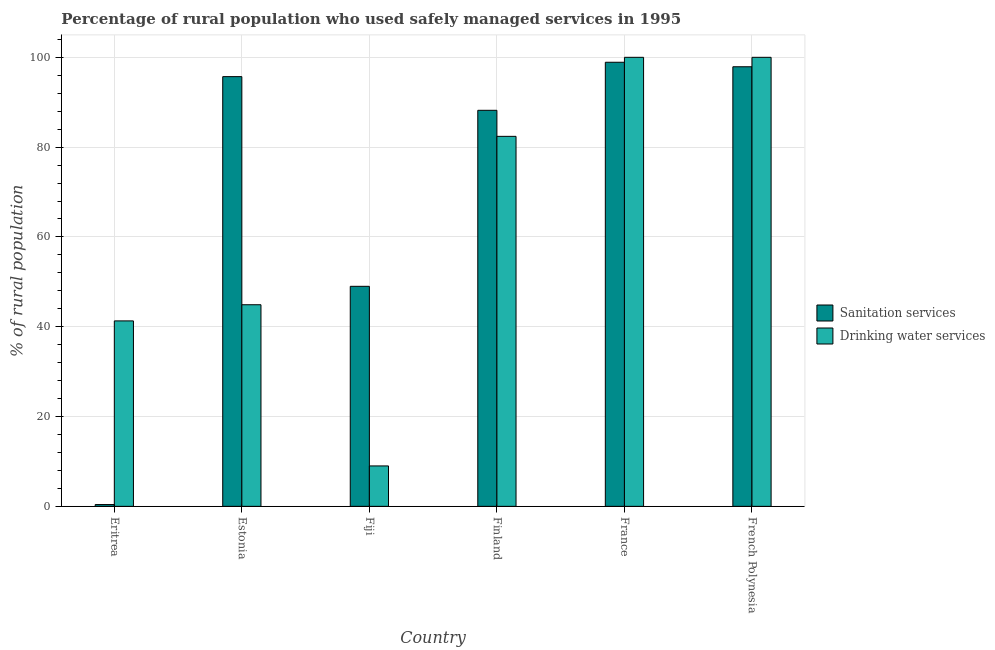How many different coloured bars are there?
Offer a terse response. 2. How many groups of bars are there?
Keep it short and to the point. 6. What is the label of the 2nd group of bars from the left?
Offer a very short reply. Estonia. In how many cases, is the number of bars for a given country not equal to the number of legend labels?
Provide a short and direct response. 0. What is the percentage of rural population who used sanitation services in France?
Ensure brevity in your answer.  98.9. Across all countries, what is the maximum percentage of rural population who used sanitation services?
Ensure brevity in your answer.  98.9. Across all countries, what is the minimum percentage of rural population who used drinking water services?
Your answer should be very brief. 9. In which country was the percentage of rural population who used sanitation services maximum?
Ensure brevity in your answer.  France. In which country was the percentage of rural population who used sanitation services minimum?
Offer a terse response. Eritrea. What is the total percentage of rural population who used drinking water services in the graph?
Keep it short and to the point. 377.6. What is the difference between the percentage of rural population who used drinking water services in Estonia and that in France?
Offer a very short reply. -55.1. What is the difference between the percentage of rural population who used sanitation services in Fiji and the percentage of rural population who used drinking water services in Eritrea?
Offer a very short reply. 7.7. What is the average percentage of rural population who used drinking water services per country?
Ensure brevity in your answer.  62.93. What is the difference between the percentage of rural population who used drinking water services and percentage of rural population who used sanitation services in Finland?
Keep it short and to the point. -5.8. In how many countries, is the percentage of rural population who used sanitation services greater than 28 %?
Your answer should be very brief. 5. What is the ratio of the percentage of rural population who used drinking water services in Estonia to that in Fiji?
Your answer should be compact. 4.99. Is the difference between the percentage of rural population who used drinking water services in Finland and France greater than the difference between the percentage of rural population who used sanitation services in Finland and France?
Your answer should be compact. No. What is the difference between the highest and the lowest percentage of rural population who used sanitation services?
Offer a terse response. 98.5. What does the 1st bar from the left in Finland represents?
Provide a succinct answer. Sanitation services. What does the 1st bar from the right in Finland represents?
Your response must be concise. Drinking water services. How many bars are there?
Ensure brevity in your answer.  12. Are all the bars in the graph horizontal?
Your answer should be very brief. No. How many countries are there in the graph?
Keep it short and to the point. 6. Are the values on the major ticks of Y-axis written in scientific E-notation?
Your response must be concise. No. Does the graph contain any zero values?
Keep it short and to the point. No. Where does the legend appear in the graph?
Give a very brief answer. Center right. What is the title of the graph?
Your response must be concise. Percentage of rural population who used safely managed services in 1995. Does "Male labor force" appear as one of the legend labels in the graph?
Give a very brief answer. No. What is the label or title of the X-axis?
Keep it short and to the point. Country. What is the label or title of the Y-axis?
Your answer should be very brief. % of rural population. What is the % of rural population in Sanitation services in Eritrea?
Ensure brevity in your answer.  0.4. What is the % of rural population of Drinking water services in Eritrea?
Your answer should be very brief. 41.3. What is the % of rural population of Sanitation services in Estonia?
Offer a terse response. 95.7. What is the % of rural population of Drinking water services in Estonia?
Make the answer very short. 44.9. What is the % of rural population of Drinking water services in Fiji?
Offer a very short reply. 9. What is the % of rural population of Sanitation services in Finland?
Ensure brevity in your answer.  88.2. What is the % of rural population in Drinking water services in Finland?
Offer a very short reply. 82.4. What is the % of rural population of Sanitation services in France?
Offer a terse response. 98.9. What is the % of rural population of Drinking water services in France?
Give a very brief answer. 100. What is the % of rural population of Sanitation services in French Polynesia?
Provide a succinct answer. 97.9. Across all countries, what is the maximum % of rural population of Sanitation services?
Your response must be concise. 98.9. Across all countries, what is the minimum % of rural population in Sanitation services?
Keep it short and to the point. 0.4. Across all countries, what is the minimum % of rural population in Drinking water services?
Your answer should be very brief. 9. What is the total % of rural population of Sanitation services in the graph?
Your answer should be very brief. 430.1. What is the total % of rural population of Drinking water services in the graph?
Your answer should be very brief. 377.6. What is the difference between the % of rural population of Sanitation services in Eritrea and that in Estonia?
Your response must be concise. -95.3. What is the difference between the % of rural population of Drinking water services in Eritrea and that in Estonia?
Give a very brief answer. -3.6. What is the difference between the % of rural population in Sanitation services in Eritrea and that in Fiji?
Your response must be concise. -48.6. What is the difference between the % of rural population of Drinking water services in Eritrea and that in Fiji?
Ensure brevity in your answer.  32.3. What is the difference between the % of rural population in Sanitation services in Eritrea and that in Finland?
Offer a very short reply. -87.8. What is the difference between the % of rural population in Drinking water services in Eritrea and that in Finland?
Offer a very short reply. -41.1. What is the difference between the % of rural population in Sanitation services in Eritrea and that in France?
Ensure brevity in your answer.  -98.5. What is the difference between the % of rural population in Drinking water services in Eritrea and that in France?
Provide a short and direct response. -58.7. What is the difference between the % of rural population in Sanitation services in Eritrea and that in French Polynesia?
Provide a short and direct response. -97.5. What is the difference between the % of rural population of Drinking water services in Eritrea and that in French Polynesia?
Offer a terse response. -58.7. What is the difference between the % of rural population in Sanitation services in Estonia and that in Fiji?
Give a very brief answer. 46.7. What is the difference between the % of rural population in Drinking water services in Estonia and that in Fiji?
Your answer should be compact. 35.9. What is the difference between the % of rural population of Drinking water services in Estonia and that in Finland?
Keep it short and to the point. -37.5. What is the difference between the % of rural population of Sanitation services in Estonia and that in France?
Your answer should be compact. -3.2. What is the difference between the % of rural population in Drinking water services in Estonia and that in France?
Provide a succinct answer. -55.1. What is the difference between the % of rural population in Sanitation services in Estonia and that in French Polynesia?
Ensure brevity in your answer.  -2.2. What is the difference between the % of rural population in Drinking water services in Estonia and that in French Polynesia?
Give a very brief answer. -55.1. What is the difference between the % of rural population in Sanitation services in Fiji and that in Finland?
Offer a very short reply. -39.2. What is the difference between the % of rural population in Drinking water services in Fiji and that in Finland?
Make the answer very short. -73.4. What is the difference between the % of rural population of Sanitation services in Fiji and that in France?
Offer a very short reply. -49.9. What is the difference between the % of rural population in Drinking water services in Fiji and that in France?
Provide a short and direct response. -91. What is the difference between the % of rural population in Sanitation services in Fiji and that in French Polynesia?
Your answer should be compact. -48.9. What is the difference between the % of rural population in Drinking water services in Fiji and that in French Polynesia?
Your response must be concise. -91. What is the difference between the % of rural population of Sanitation services in Finland and that in France?
Your response must be concise. -10.7. What is the difference between the % of rural population of Drinking water services in Finland and that in France?
Give a very brief answer. -17.6. What is the difference between the % of rural population of Sanitation services in Finland and that in French Polynesia?
Your answer should be compact. -9.7. What is the difference between the % of rural population of Drinking water services in Finland and that in French Polynesia?
Offer a very short reply. -17.6. What is the difference between the % of rural population in Drinking water services in France and that in French Polynesia?
Provide a succinct answer. 0. What is the difference between the % of rural population in Sanitation services in Eritrea and the % of rural population in Drinking water services in Estonia?
Keep it short and to the point. -44.5. What is the difference between the % of rural population in Sanitation services in Eritrea and the % of rural population in Drinking water services in Fiji?
Give a very brief answer. -8.6. What is the difference between the % of rural population in Sanitation services in Eritrea and the % of rural population in Drinking water services in Finland?
Give a very brief answer. -82. What is the difference between the % of rural population of Sanitation services in Eritrea and the % of rural population of Drinking water services in France?
Provide a short and direct response. -99.6. What is the difference between the % of rural population in Sanitation services in Eritrea and the % of rural population in Drinking water services in French Polynesia?
Your answer should be very brief. -99.6. What is the difference between the % of rural population in Sanitation services in Estonia and the % of rural population in Drinking water services in Fiji?
Offer a very short reply. 86.7. What is the difference between the % of rural population of Sanitation services in Estonia and the % of rural population of Drinking water services in France?
Offer a very short reply. -4.3. What is the difference between the % of rural population of Sanitation services in Fiji and the % of rural population of Drinking water services in Finland?
Make the answer very short. -33.4. What is the difference between the % of rural population of Sanitation services in Fiji and the % of rural population of Drinking water services in France?
Your answer should be very brief. -51. What is the difference between the % of rural population of Sanitation services in Fiji and the % of rural population of Drinking water services in French Polynesia?
Ensure brevity in your answer.  -51. What is the difference between the % of rural population of Sanitation services in Finland and the % of rural population of Drinking water services in France?
Your response must be concise. -11.8. What is the difference between the % of rural population in Sanitation services in France and the % of rural population in Drinking water services in French Polynesia?
Your answer should be compact. -1.1. What is the average % of rural population of Sanitation services per country?
Ensure brevity in your answer.  71.68. What is the average % of rural population in Drinking water services per country?
Your answer should be compact. 62.93. What is the difference between the % of rural population of Sanitation services and % of rural population of Drinking water services in Eritrea?
Give a very brief answer. -40.9. What is the difference between the % of rural population of Sanitation services and % of rural population of Drinking water services in Estonia?
Your response must be concise. 50.8. What is the difference between the % of rural population in Sanitation services and % of rural population in Drinking water services in Fiji?
Give a very brief answer. 40. What is the difference between the % of rural population of Sanitation services and % of rural population of Drinking water services in Finland?
Offer a terse response. 5.8. What is the difference between the % of rural population in Sanitation services and % of rural population in Drinking water services in French Polynesia?
Provide a succinct answer. -2.1. What is the ratio of the % of rural population of Sanitation services in Eritrea to that in Estonia?
Provide a succinct answer. 0. What is the ratio of the % of rural population in Drinking water services in Eritrea to that in Estonia?
Provide a succinct answer. 0.92. What is the ratio of the % of rural population in Sanitation services in Eritrea to that in Fiji?
Give a very brief answer. 0.01. What is the ratio of the % of rural population of Drinking water services in Eritrea to that in Fiji?
Give a very brief answer. 4.59. What is the ratio of the % of rural population in Sanitation services in Eritrea to that in Finland?
Your answer should be very brief. 0. What is the ratio of the % of rural population of Drinking water services in Eritrea to that in Finland?
Make the answer very short. 0.5. What is the ratio of the % of rural population of Sanitation services in Eritrea to that in France?
Give a very brief answer. 0. What is the ratio of the % of rural population in Drinking water services in Eritrea to that in France?
Offer a very short reply. 0.41. What is the ratio of the % of rural population of Sanitation services in Eritrea to that in French Polynesia?
Your answer should be very brief. 0. What is the ratio of the % of rural population of Drinking water services in Eritrea to that in French Polynesia?
Make the answer very short. 0.41. What is the ratio of the % of rural population in Sanitation services in Estonia to that in Fiji?
Offer a very short reply. 1.95. What is the ratio of the % of rural population in Drinking water services in Estonia to that in Fiji?
Provide a short and direct response. 4.99. What is the ratio of the % of rural population of Sanitation services in Estonia to that in Finland?
Keep it short and to the point. 1.08. What is the ratio of the % of rural population in Drinking water services in Estonia to that in Finland?
Make the answer very short. 0.54. What is the ratio of the % of rural population of Sanitation services in Estonia to that in France?
Your answer should be very brief. 0.97. What is the ratio of the % of rural population of Drinking water services in Estonia to that in France?
Offer a terse response. 0.45. What is the ratio of the % of rural population in Sanitation services in Estonia to that in French Polynesia?
Provide a short and direct response. 0.98. What is the ratio of the % of rural population of Drinking water services in Estonia to that in French Polynesia?
Offer a terse response. 0.45. What is the ratio of the % of rural population in Sanitation services in Fiji to that in Finland?
Provide a succinct answer. 0.56. What is the ratio of the % of rural population of Drinking water services in Fiji to that in Finland?
Offer a very short reply. 0.11. What is the ratio of the % of rural population of Sanitation services in Fiji to that in France?
Make the answer very short. 0.5. What is the ratio of the % of rural population in Drinking water services in Fiji to that in France?
Give a very brief answer. 0.09. What is the ratio of the % of rural population of Sanitation services in Fiji to that in French Polynesia?
Your answer should be very brief. 0.5. What is the ratio of the % of rural population in Drinking water services in Fiji to that in French Polynesia?
Provide a short and direct response. 0.09. What is the ratio of the % of rural population of Sanitation services in Finland to that in France?
Make the answer very short. 0.89. What is the ratio of the % of rural population of Drinking water services in Finland to that in France?
Offer a very short reply. 0.82. What is the ratio of the % of rural population of Sanitation services in Finland to that in French Polynesia?
Ensure brevity in your answer.  0.9. What is the ratio of the % of rural population in Drinking water services in Finland to that in French Polynesia?
Offer a terse response. 0.82. What is the ratio of the % of rural population of Sanitation services in France to that in French Polynesia?
Make the answer very short. 1.01. What is the ratio of the % of rural population in Drinking water services in France to that in French Polynesia?
Give a very brief answer. 1. What is the difference between the highest and the second highest % of rural population of Sanitation services?
Your response must be concise. 1. What is the difference between the highest and the second highest % of rural population of Drinking water services?
Your answer should be very brief. 0. What is the difference between the highest and the lowest % of rural population of Sanitation services?
Offer a very short reply. 98.5. What is the difference between the highest and the lowest % of rural population of Drinking water services?
Give a very brief answer. 91. 